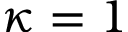Convert formula to latex. <formula><loc_0><loc_0><loc_500><loc_500>\kappa = 1</formula> 